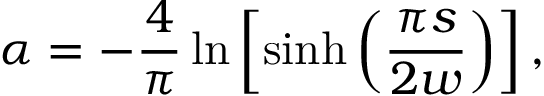Convert formula to latex. <formula><loc_0><loc_0><loc_500><loc_500>\alpha = - \frac { 4 } { \pi } \ln \left [ \sinh \left ( \frac { \pi s } { 2 w } \right ) \right ] ,</formula> 